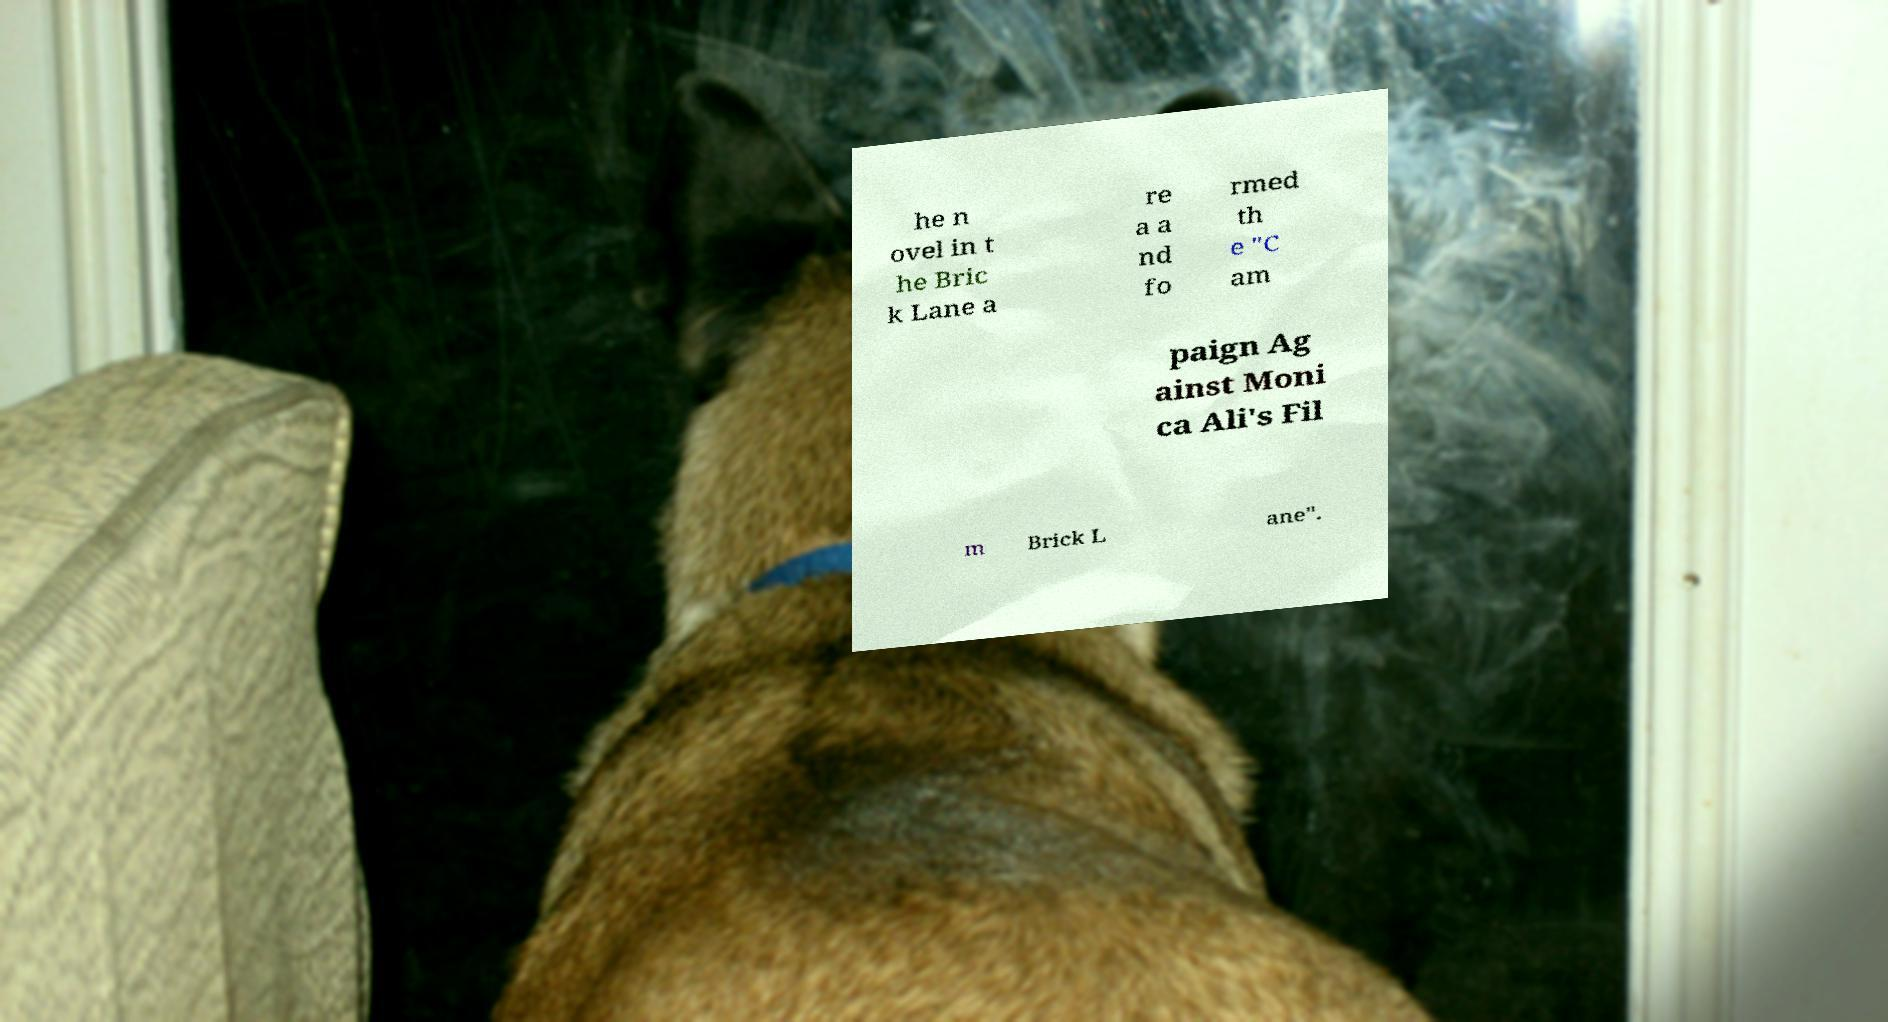Please read and relay the text visible in this image. What does it say? he n ovel in t he Bric k Lane a re a a nd fo rmed th e "C am paign Ag ainst Moni ca Ali's Fil m Brick L ane". 